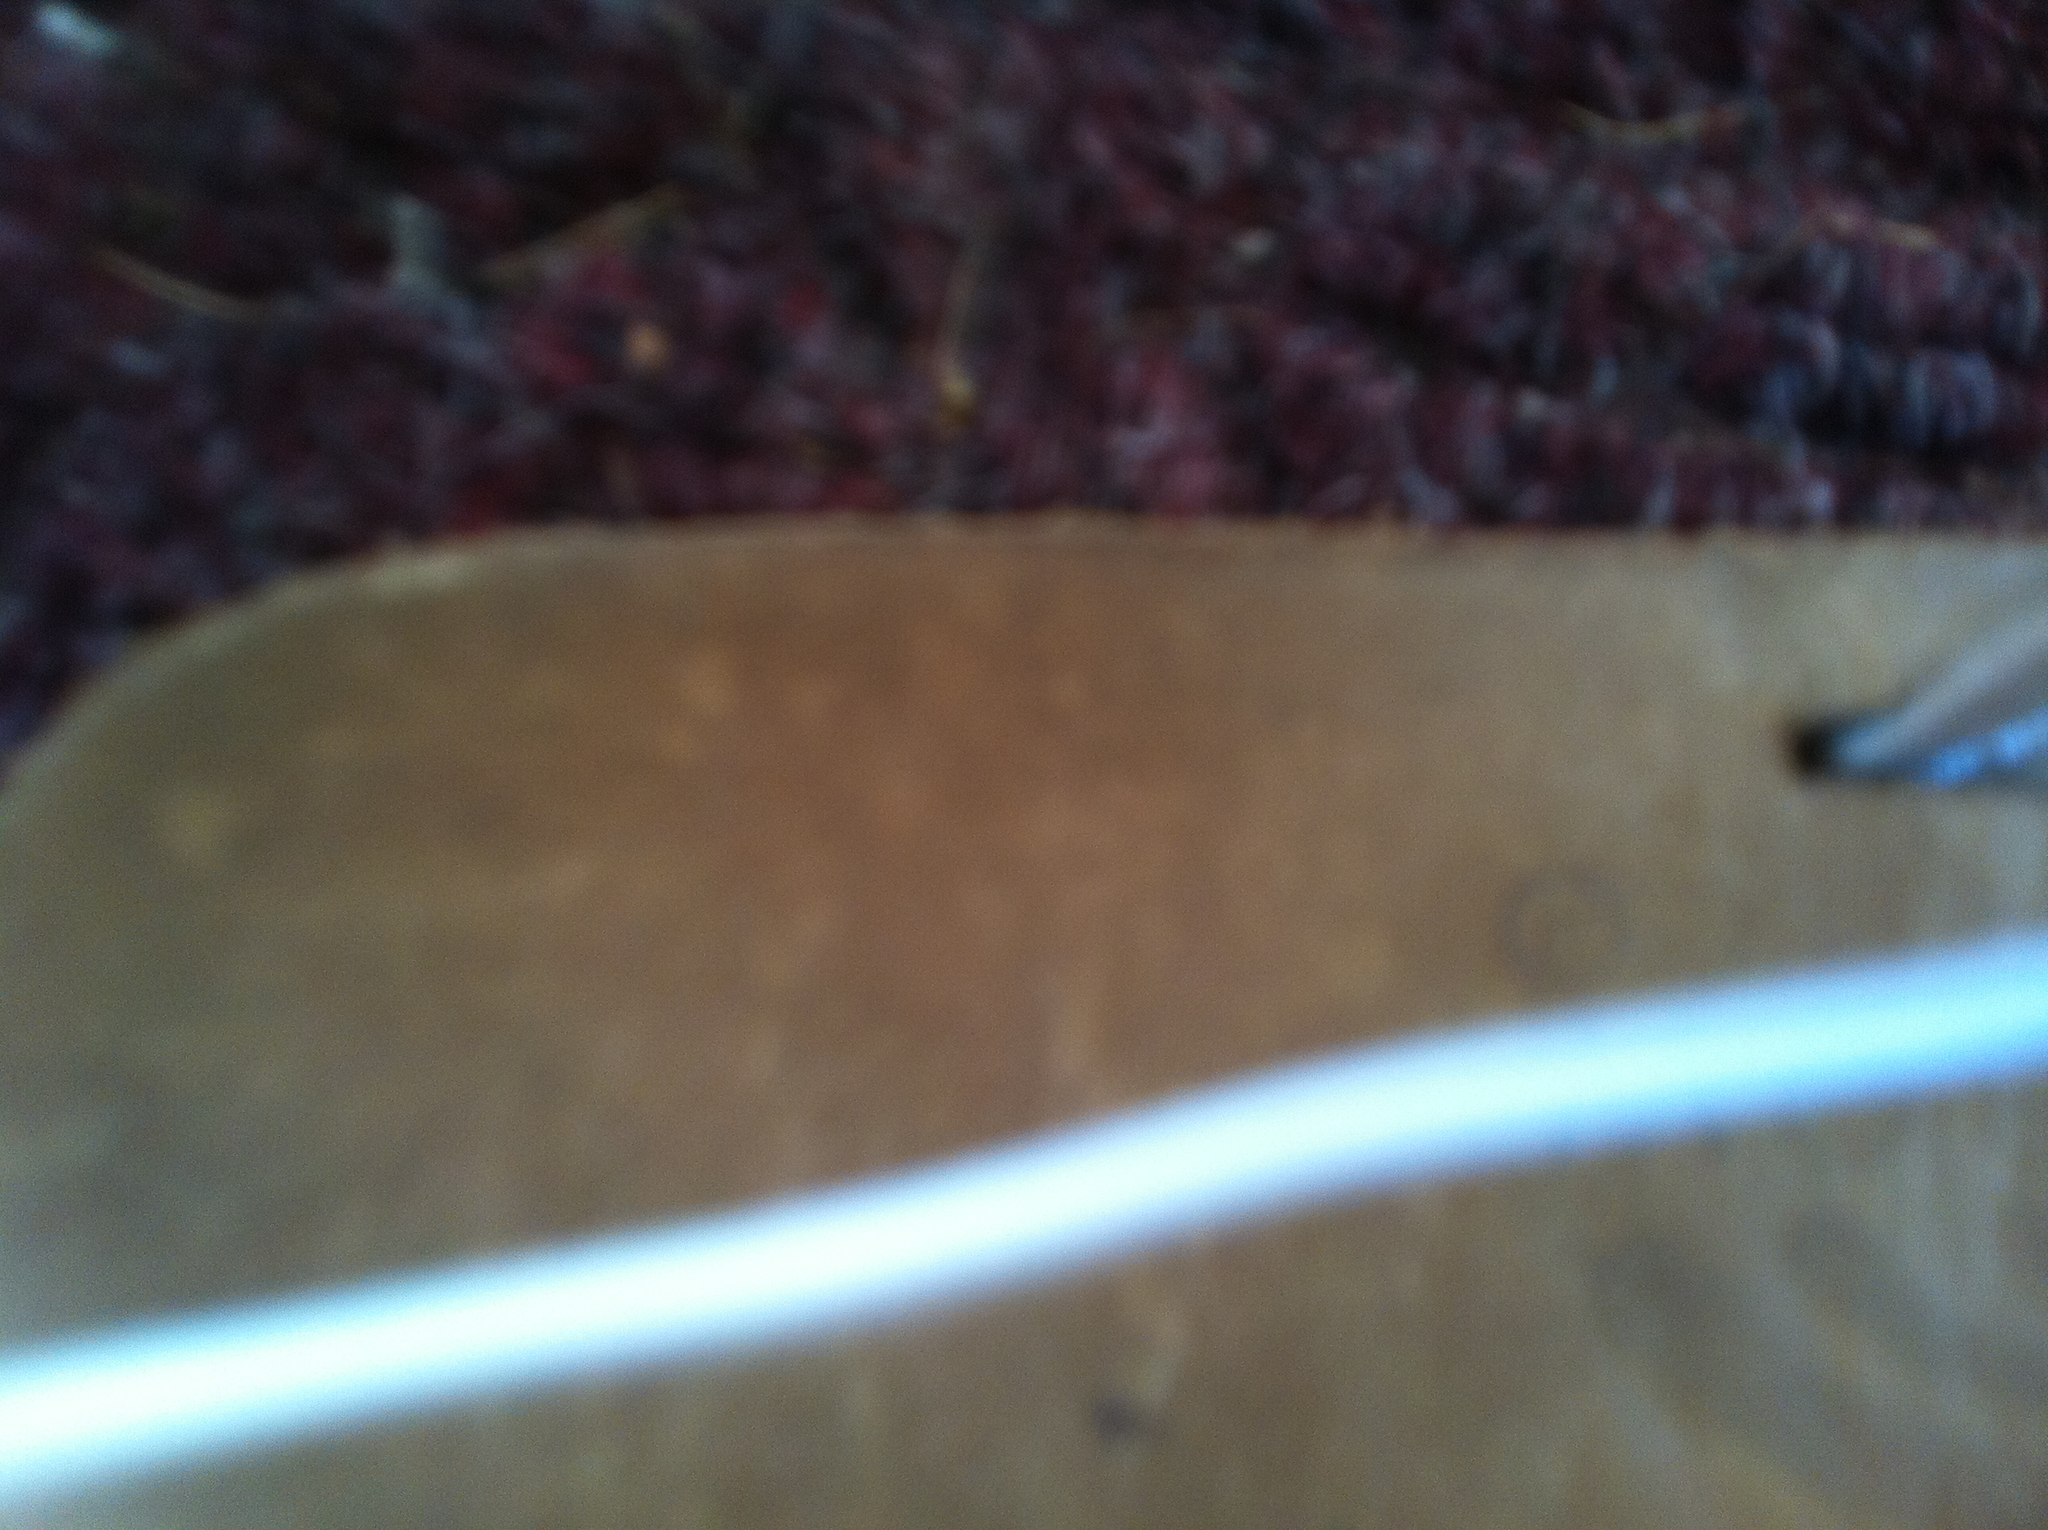Does the background provide any information about the setting of this image? The background appears to be a textured, possibly carpeted surface with a dark maroon and brown color scheme, which might indicate an indoor setting like a home or office. However, due to the image's blurriness, it's difficult to draw a definitive conclusion.  Imagine this shoe has a story, can you create an imaginative backstory for it? This shoe once belonged to a world-traveling historian, who wore it as he uncovered lost civilizations. From traversing the sands of Egyptian deserts to climbing through ancient ruins in Greece, these shoes have seen countless adventures. They’ve walked on forbidden grounds, in places where history was both made and forgotten. Now, they rest as a reminder of the stories and secrets they’ve held, quietly nestled in the comfort of a historian's study. 